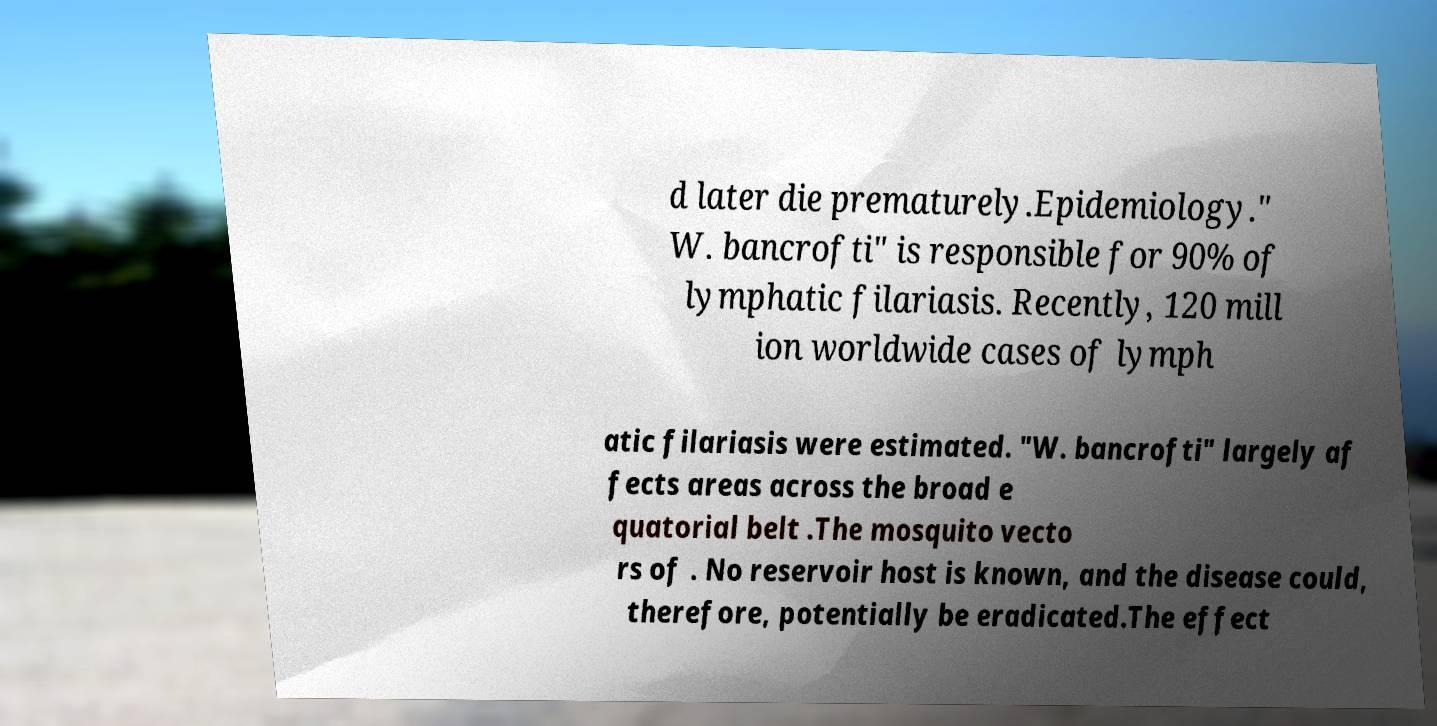For documentation purposes, I need the text within this image transcribed. Could you provide that? d later die prematurely.Epidemiology." W. bancrofti" is responsible for 90% of lymphatic filariasis. Recently, 120 mill ion worldwide cases of lymph atic filariasis were estimated. "W. bancrofti" largely af fects areas across the broad e quatorial belt .The mosquito vecto rs of . No reservoir host is known, and the disease could, therefore, potentially be eradicated.The effect 